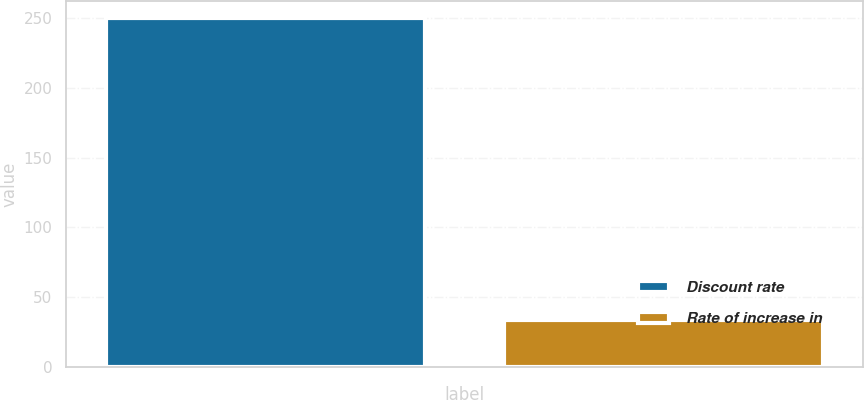Convert chart. <chart><loc_0><loc_0><loc_500><loc_500><bar_chart><fcel>Discount rate<fcel>Rate of increase in<nl><fcel>250<fcel>34<nl></chart> 